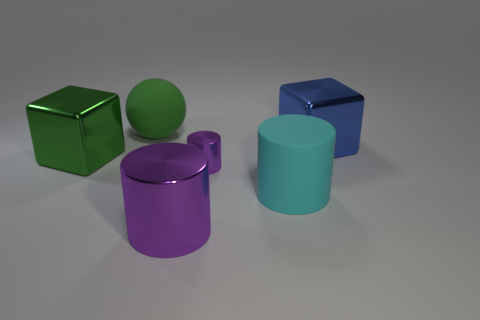Add 1 large things. How many objects exist? 7 Subtract all spheres. How many objects are left? 5 Subtract all big rubber balls. Subtract all large rubber objects. How many objects are left? 3 Add 6 large green metallic things. How many large green metallic things are left? 7 Add 6 big cyan cylinders. How many big cyan cylinders exist? 7 Subtract 0 blue cylinders. How many objects are left? 6 